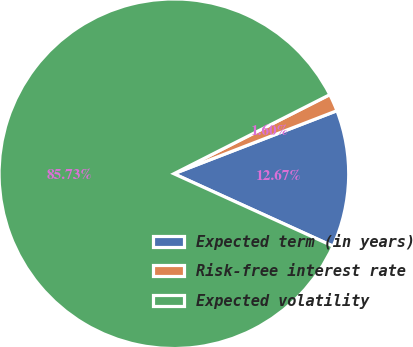Convert chart. <chart><loc_0><loc_0><loc_500><loc_500><pie_chart><fcel>Expected term (in years)<fcel>Risk-free interest rate<fcel>Expected volatility<nl><fcel>12.67%<fcel>1.6%<fcel>85.73%<nl></chart> 